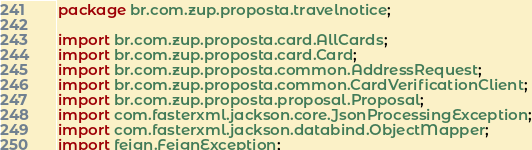Convert code to text. <code><loc_0><loc_0><loc_500><loc_500><_Java_>package br.com.zup.proposta.travelnotice;

import br.com.zup.proposta.card.AllCards;
import br.com.zup.proposta.card.Card;
import br.com.zup.proposta.common.AddressRequest;
import br.com.zup.proposta.common.CardVerificationClient;
import br.com.zup.proposta.proposal.Proposal;
import com.fasterxml.jackson.core.JsonProcessingException;
import com.fasterxml.jackson.databind.ObjectMapper;
import feign.FeignException;</code> 